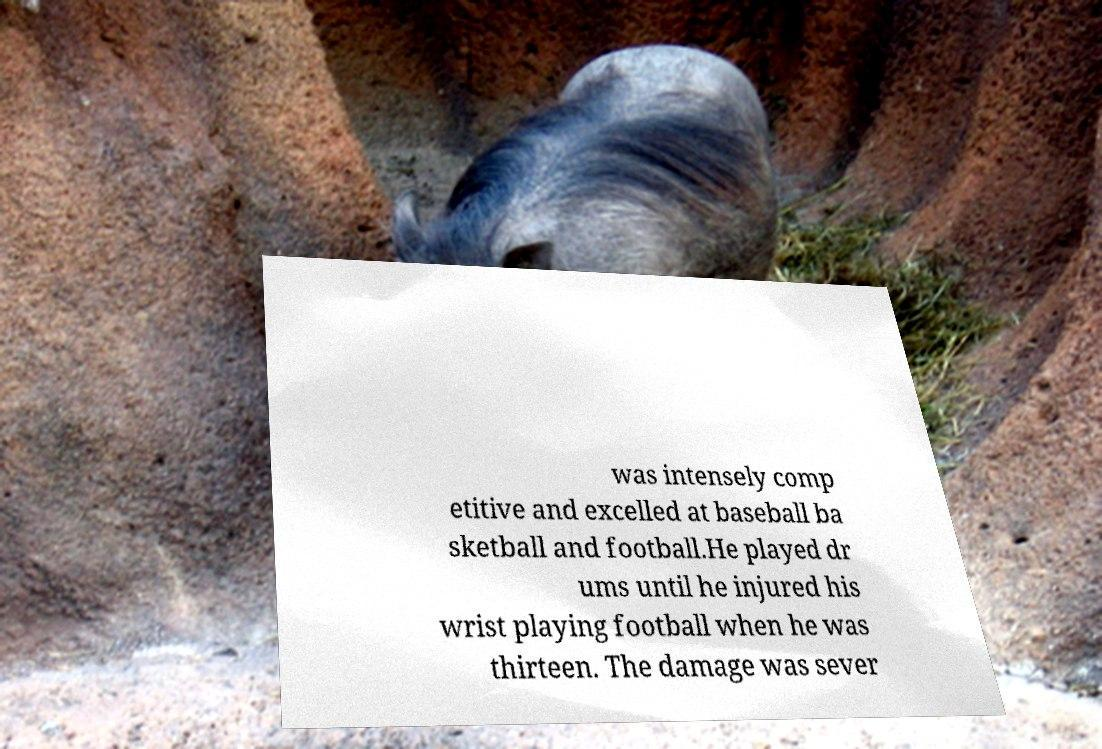Can you accurately transcribe the text from the provided image for me? was intensely comp etitive and excelled at baseball ba sketball and football.He played dr ums until he injured his wrist playing football when he was thirteen. The damage was sever 